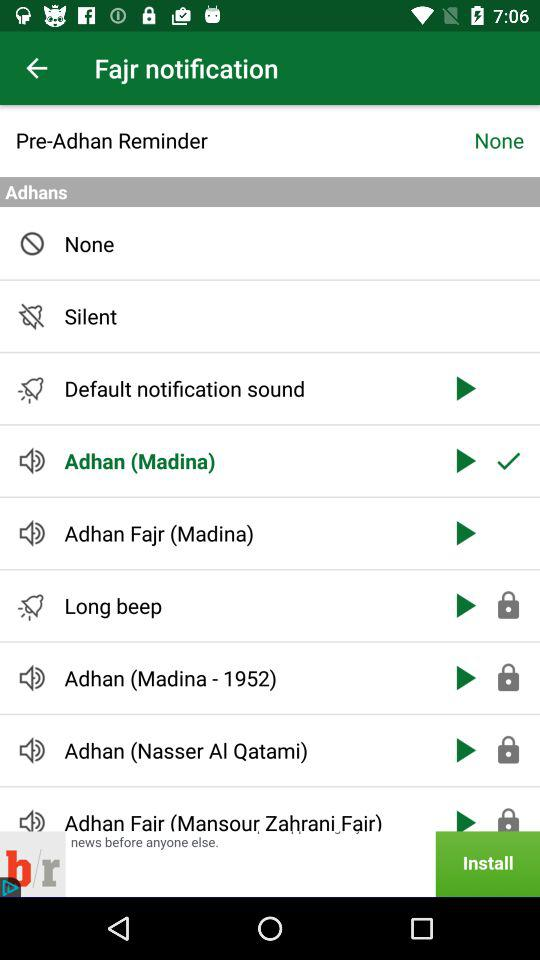Is the "Long beep" locked or not? The "Long beep" is locked. 